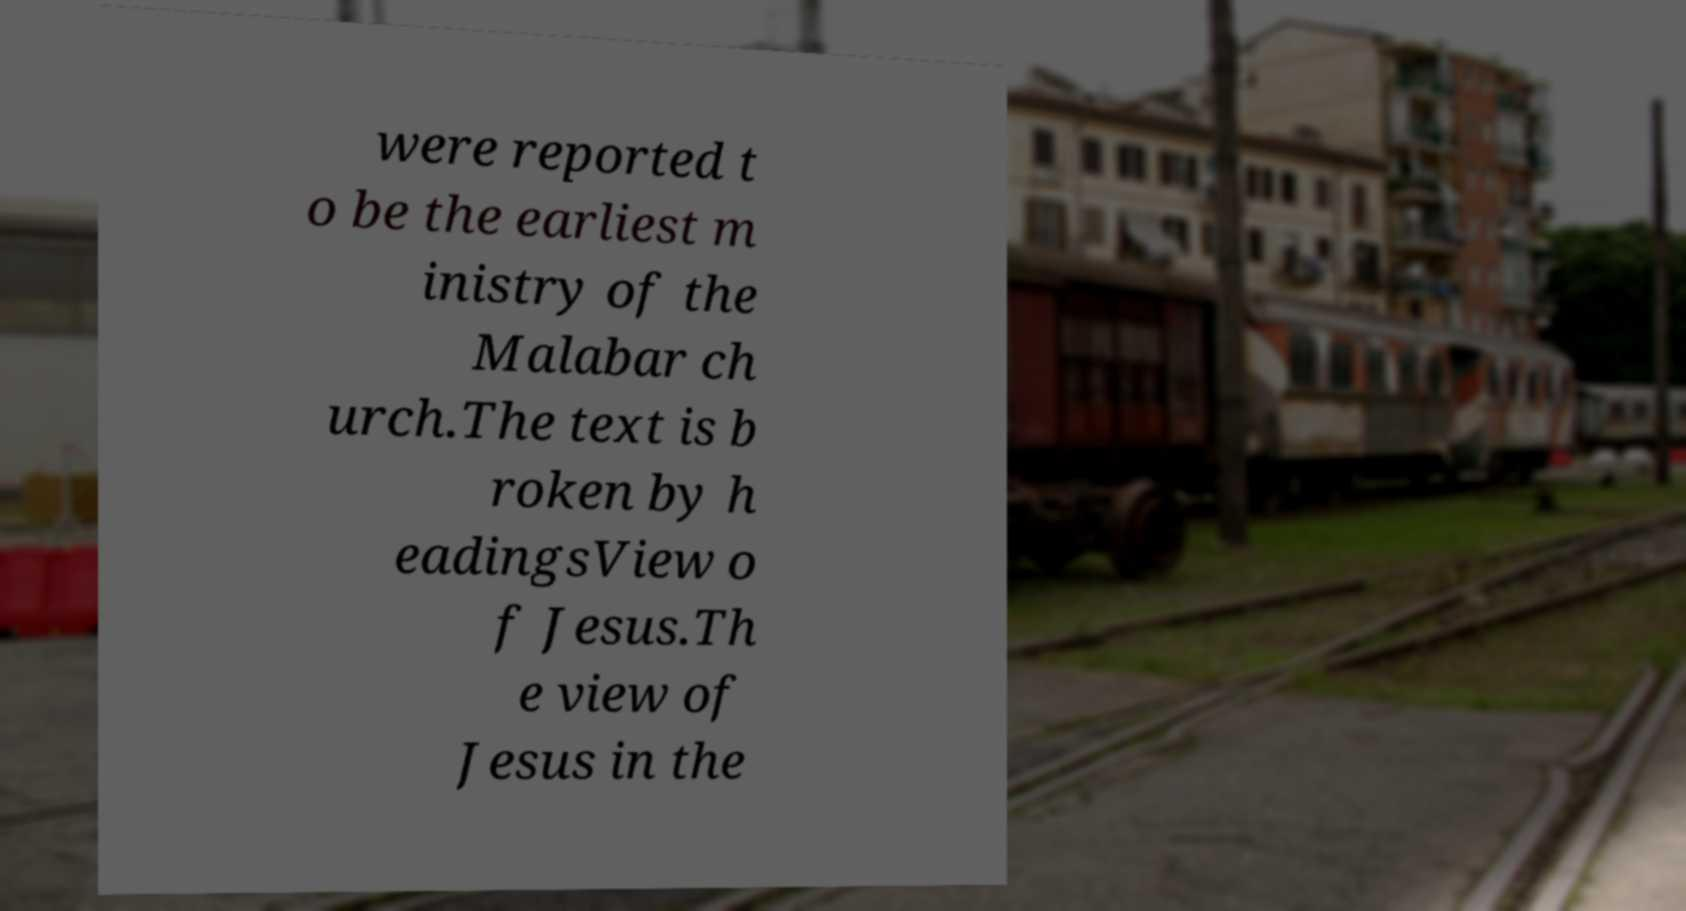Can you accurately transcribe the text from the provided image for me? were reported t o be the earliest m inistry of the Malabar ch urch.The text is b roken by h eadingsView o f Jesus.Th e view of Jesus in the 